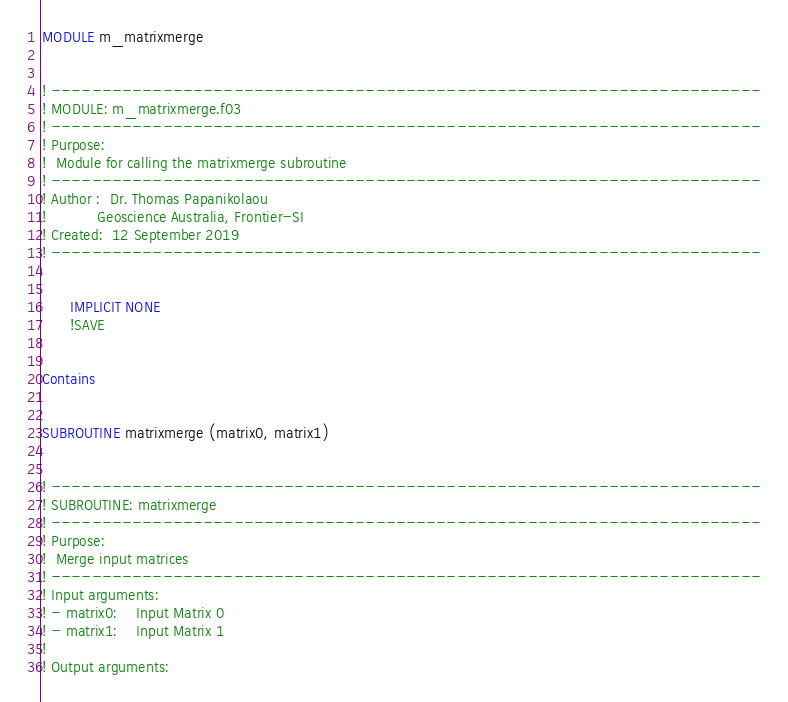Convert code to text. <code><loc_0><loc_0><loc_500><loc_500><_FORTRAN_>MODULE m_matrixmerge


! ----------------------------------------------------------------------
! MODULE: m_matrixmerge.f03
! ----------------------------------------------------------------------
! Purpose:
!  Module for calling the matrixmerge subroutine 
! ----------------------------------------------------------------------
! Author :	Dr. Thomas Papanikolaou
! 			Geoscience Australia, Frontier-SI
! Created:	12 September 2019
! ----------------------------------------------------------------------


      IMPLICIT NONE
      !SAVE 			
  
	  
Contains
	  
	  
SUBROUTINE matrixmerge (matrix0, matrix1) 


! ----------------------------------------------------------------------
! SUBROUTINE: matrixmerge
! ----------------------------------------------------------------------
! Purpose:
!  Merge input matrices 
! ----------------------------------------------------------------------
! Input arguments:
! - matrix0: 	Input Matrix 0  
! - matrix1: 	Input Matrix 1  
!
! Output arguments:</code> 